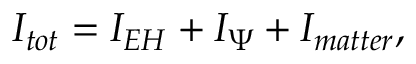<formula> <loc_0><loc_0><loc_500><loc_500>I _ { t o t } = I _ { E H } + I _ { \Psi } + I _ { m a t t e r } ,</formula> 